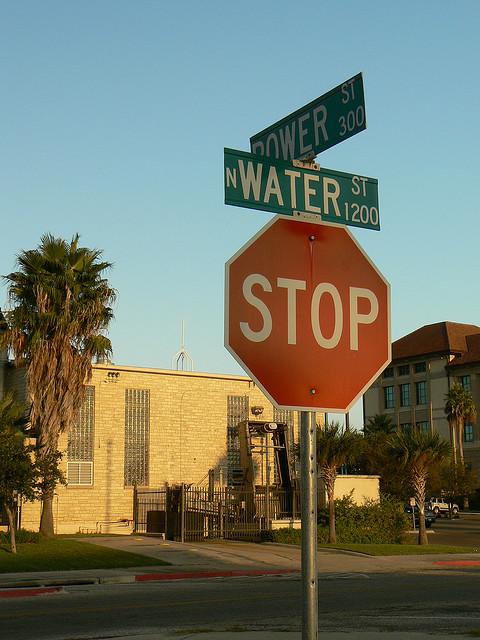Can you park on the curb?
Concise answer only. No. Would you look both ways before walking here?
Give a very brief answer. Yes. What streets intersect?
Short answer required. Power and water. What is the name of the cross street?
Be succinct. Water. What color is the sign?
Concise answer only. Red. Is there a trash can in view?
Concise answer only. No. What street is this?
Keep it brief. Water. What kind of flowers are blooming?
Concise answer only. None. Is the street sign in good condition?
Give a very brief answer. Yes. What street is on top?
Quick response, please. Power. In what language is the sign written?
Be succinct. English. What is the name on the top line of the sign?
Keep it brief. Power. What does the sign say?
Be succinct. Stop. What is the name of the street?
Short answer required. Water. Is there traffic?
Be succinct. No. What does the stop sign mean?
Short answer required. Stop. What street is this picture taken on?
Be succinct. Water. How many green signs are there?
Quick response, please. 2. What street is this by?
Quick response, please. Water. Is the pole to the stop sign made out of metal?
Answer briefly. Yes. What roads are at the intersection?
Be succinct. Power and water. Do you see clouds?
Be succinct. No. Is there a sticker on the Stop sign?
Quick response, please. No. Is there an icon of a man on a neon sign?
Give a very brief answer. No. Are there leaves on the trees?
Quick response, please. Yes. 